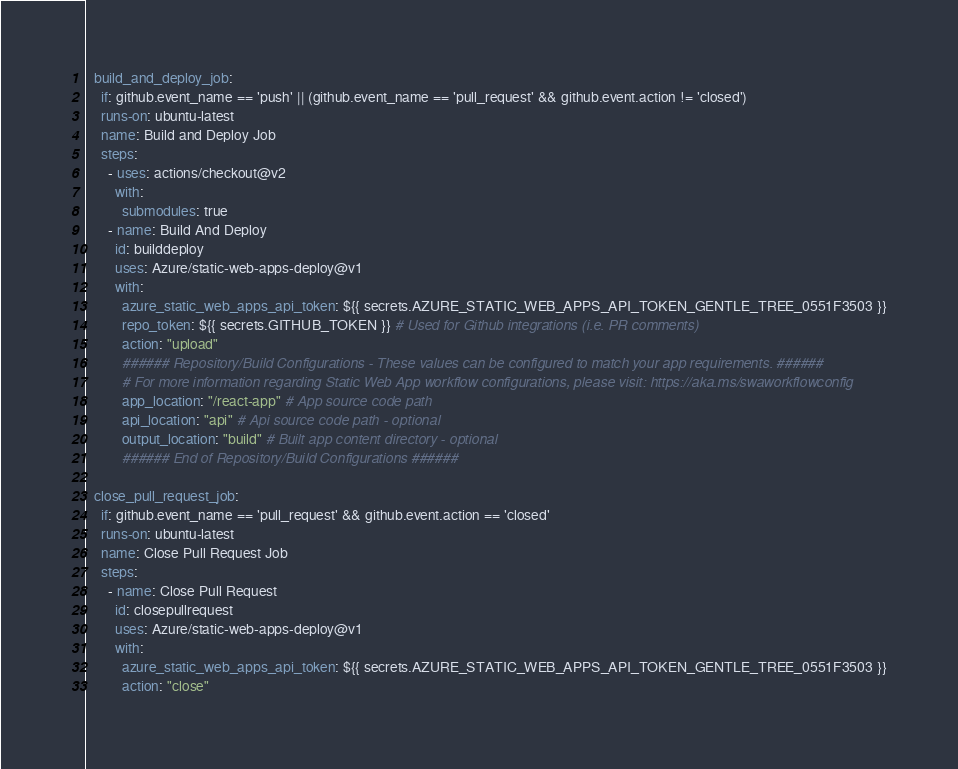Convert code to text. <code><loc_0><loc_0><loc_500><loc_500><_YAML_>  build_and_deploy_job:
    if: github.event_name == 'push' || (github.event_name == 'pull_request' && github.event.action != 'closed')
    runs-on: ubuntu-latest
    name: Build and Deploy Job
    steps:
      - uses: actions/checkout@v2
        with:
          submodules: true
      - name: Build And Deploy
        id: builddeploy
        uses: Azure/static-web-apps-deploy@v1
        with:
          azure_static_web_apps_api_token: ${{ secrets.AZURE_STATIC_WEB_APPS_API_TOKEN_GENTLE_TREE_0551F3503 }}
          repo_token: ${{ secrets.GITHUB_TOKEN }} # Used for Github integrations (i.e. PR comments)
          action: "upload"
          ###### Repository/Build Configurations - These values can be configured to match your app requirements. ######
          # For more information regarding Static Web App workflow configurations, please visit: https://aka.ms/swaworkflowconfig
          app_location: "/react-app" # App source code path
          api_location: "api" # Api source code path - optional
          output_location: "build" # Built app content directory - optional
          ###### End of Repository/Build Configurations ######

  close_pull_request_job:
    if: github.event_name == 'pull_request' && github.event.action == 'closed'
    runs-on: ubuntu-latest
    name: Close Pull Request Job
    steps:
      - name: Close Pull Request
        id: closepullrequest
        uses: Azure/static-web-apps-deploy@v1
        with:
          azure_static_web_apps_api_token: ${{ secrets.AZURE_STATIC_WEB_APPS_API_TOKEN_GENTLE_TREE_0551F3503 }}
          action: "close"
</code> 